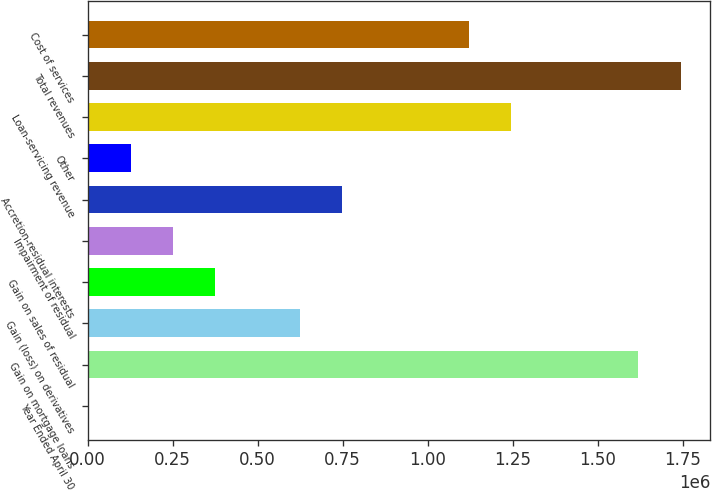Convert chart. <chart><loc_0><loc_0><loc_500><loc_500><bar_chart><fcel>Year Ended April 30<fcel>Gain on mortgage loans<fcel>Gain (loss) on derivatives<fcel>Gain on sales of residual<fcel>Impairment of residual<fcel>Accretion-residual interests<fcel>Other<fcel>Loan-servicing revenue<fcel>Total revenues<fcel>Cost of services<nl><fcel>2005<fcel>1.61922e+06<fcel>624012<fcel>375209<fcel>250808<fcel>748413<fcel>126406<fcel>1.24602e+06<fcel>1.74362e+06<fcel>1.12162e+06<nl></chart> 